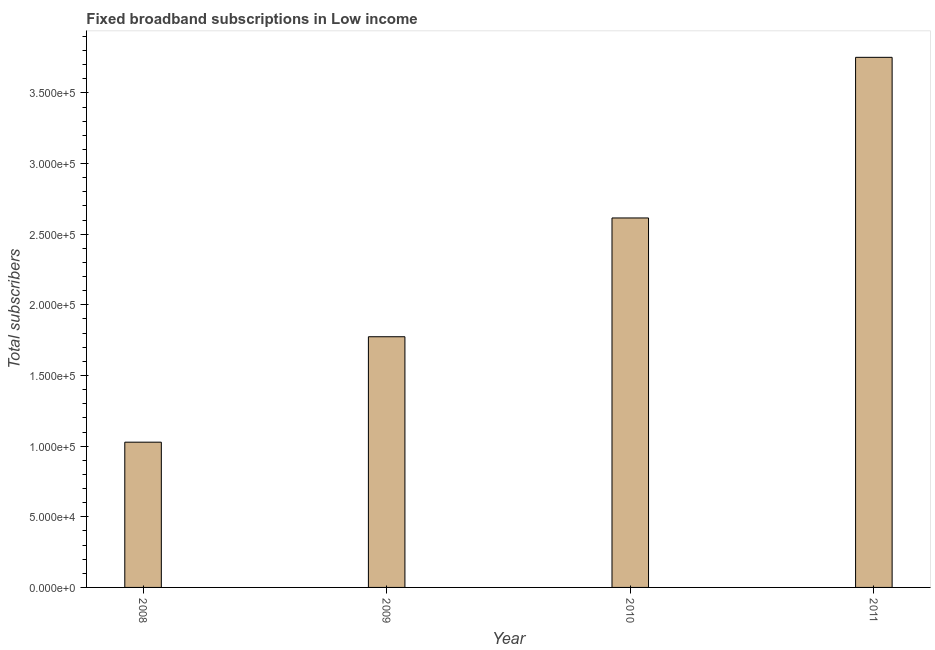Does the graph contain any zero values?
Your answer should be compact. No. Does the graph contain grids?
Ensure brevity in your answer.  No. What is the title of the graph?
Provide a short and direct response. Fixed broadband subscriptions in Low income. What is the label or title of the X-axis?
Make the answer very short. Year. What is the label or title of the Y-axis?
Your response must be concise. Total subscribers. What is the total number of fixed broadband subscriptions in 2011?
Offer a very short reply. 3.75e+05. Across all years, what is the maximum total number of fixed broadband subscriptions?
Offer a very short reply. 3.75e+05. Across all years, what is the minimum total number of fixed broadband subscriptions?
Offer a very short reply. 1.03e+05. In which year was the total number of fixed broadband subscriptions maximum?
Make the answer very short. 2011. What is the sum of the total number of fixed broadband subscriptions?
Ensure brevity in your answer.  9.17e+05. What is the difference between the total number of fixed broadband subscriptions in 2010 and 2011?
Your answer should be very brief. -1.14e+05. What is the average total number of fixed broadband subscriptions per year?
Offer a terse response. 2.29e+05. What is the median total number of fixed broadband subscriptions?
Give a very brief answer. 2.19e+05. What is the ratio of the total number of fixed broadband subscriptions in 2008 to that in 2011?
Make the answer very short. 0.27. Is the total number of fixed broadband subscriptions in 2008 less than that in 2010?
Make the answer very short. Yes. Is the difference between the total number of fixed broadband subscriptions in 2009 and 2011 greater than the difference between any two years?
Provide a short and direct response. No. What is the difference between the highest and the second highest total number of fixed broadband subscriptions?
Give a very brief answer. 1.14e+05. Is the sum of the total number of fixed broadband subscriptions in 2008 and 2011 greater than the maximum total number of fixed broadband subscriptions across all years?
Give a very brief answer. Yes. What is the difference between the highest and the lowest total number of fixed broadband subscriptions?
Provide a succinct answer. 2.72e+05. How many bars are there?
Ensure brevity in your answer.  4. Are all the bars in the graph horizontal?
Provide a succinct answer. No. What is the difference between two consecutive major ticks on the Y-axis?
Keep it short and to the point. 5.00e+04. Are the values on the major ticks of Y-axis written in scientific E-notation?
Your answer should be very brief. Yes. What is the Total subscribers in 2008?
Ensure brevity in your answer.  1.03e+05. What is the Total subscribers in 2009?
Provide a short and direct response. 1.77e+05. What is the Total subscribers of 2010?
Offer a very short reply. 2.62e+05. What is the Total subscribers of 2011?
Provide a succinct answer. 3.75e+05. What is the difference between the Total subscribers in 2008 and 2009?
Your answer should be very brief. -7.46e+04. What is the difference between the Total subscribers in 2008 and 2010?
Your answer should be compact. -1.59e+05. What is the difference between the Total subscribers in 2008 and 2011?
Your answer should be compact. -2.72e+05. What is the difference between the Total subscribers in 2009 and 2010?
Offer a very short reply. -8.41e+04. What is the difference between the Total subscribers in 2009 and 2011?
Offer a very short reply. -1.98e+05. What is the difference between the Total subscribers in 2010 and 2011?
Offer a very short reply. -1.14e+05. What is the ratio of the Total subscribers in 2008 to that in 2009?
Provide a succinct answer. 0.58. What is the ratio of the Total subscribers in 2008 to that in 2010?
Ensure brevity in your answer.  0.39. What is the ratio of the Total subscribers in 2008 to that in 2011?
Offer a terse response. 0.27. What is the ratio of the Total subscribers in 2009 to that in 2010?
Give a very brief answer. 0.68. What is the ratio of the Total subscribers in 2009 to that in 2011?
Make the answer very short. 0.47. What is the ratio of the Total subscribers in 2010 to that in 2011?
Provide a short and direct response. 0.7. 